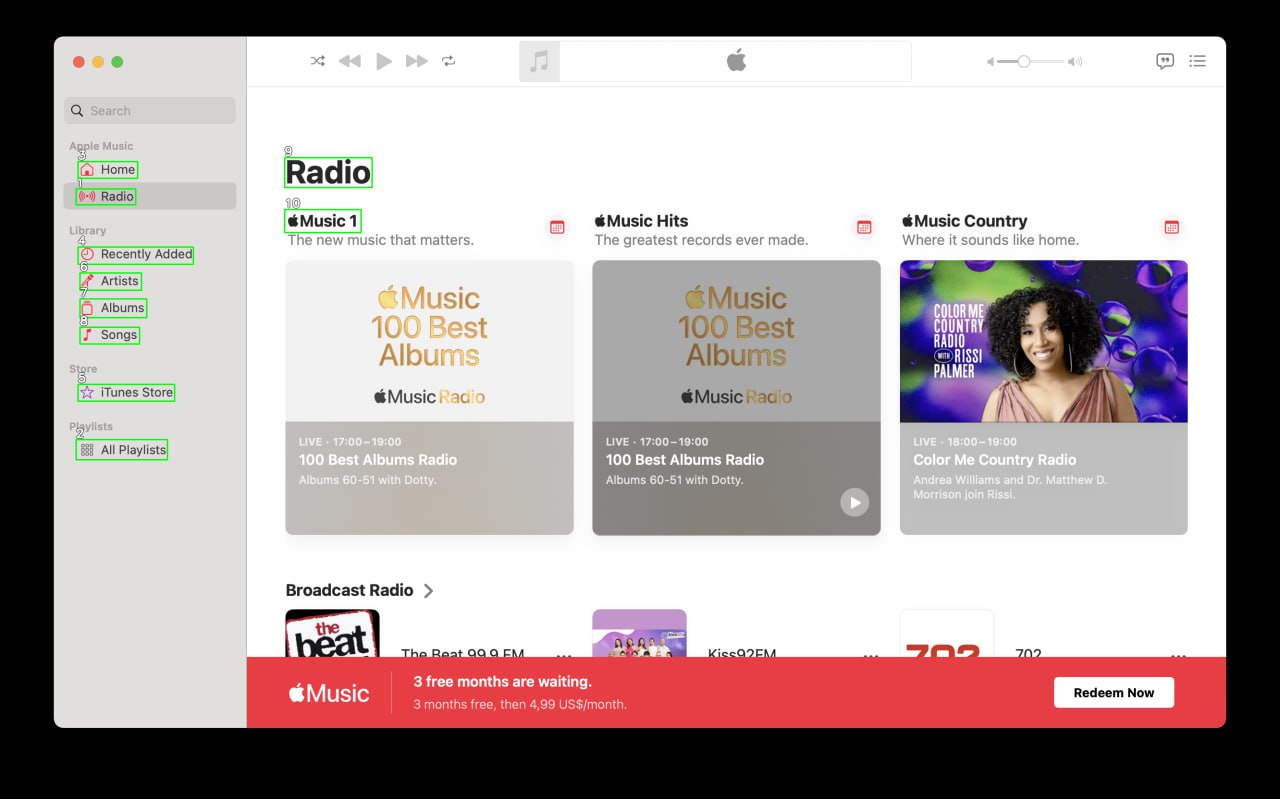Your task is to analyze the screenshot of the {app_name} on MacOS.  The screenshot is segmented with bounding boxes, each labeled with a number. The labels are always white numbers with a black outline. Number is always situated in the top left corner above the box. Describe each of the boxes numbered 1 to 10. For each identified element, provide a description that correlates with its functionality. If the element type is AXImage, write an alternative text describing the image content. Include text from the box if it is presented. Provide the output in the JSON format. ```json
{
  "1": {
    "element_type": "AXTextField",
    "description": "Search bar"
  },
  "2": {
    "element_type": "AXStaticText",
    "description": "Apple Music",
    "text": "Apple Music"
  },
  "3": {
    "element_type": "AXButton",
    "description": "Home button"
  },
  "4": {
    "element_type": "AXButton",
    "description": "Radio button"
  },
  "5": {
    "element_type": "AXStaticText",
    "description": "Library",
    "text": "Library"
  },
  "6": {
    "element_type": "AXButton",
    "description": "Recently Added button"
  },
  "7": {
    "element_type": "AXButton",
    "description": "Artists button"
  },
  "8": {
    "element_type": "AXButton",
    "description": "Albums button"
  },
  "9": {
    "element_type": "AXButton",
    "description": "Songs button"
  },
  "10": {
    "element_type": "AXStaticText",
    "description": "Store",
    "text": "Store"
  }
}
``` 